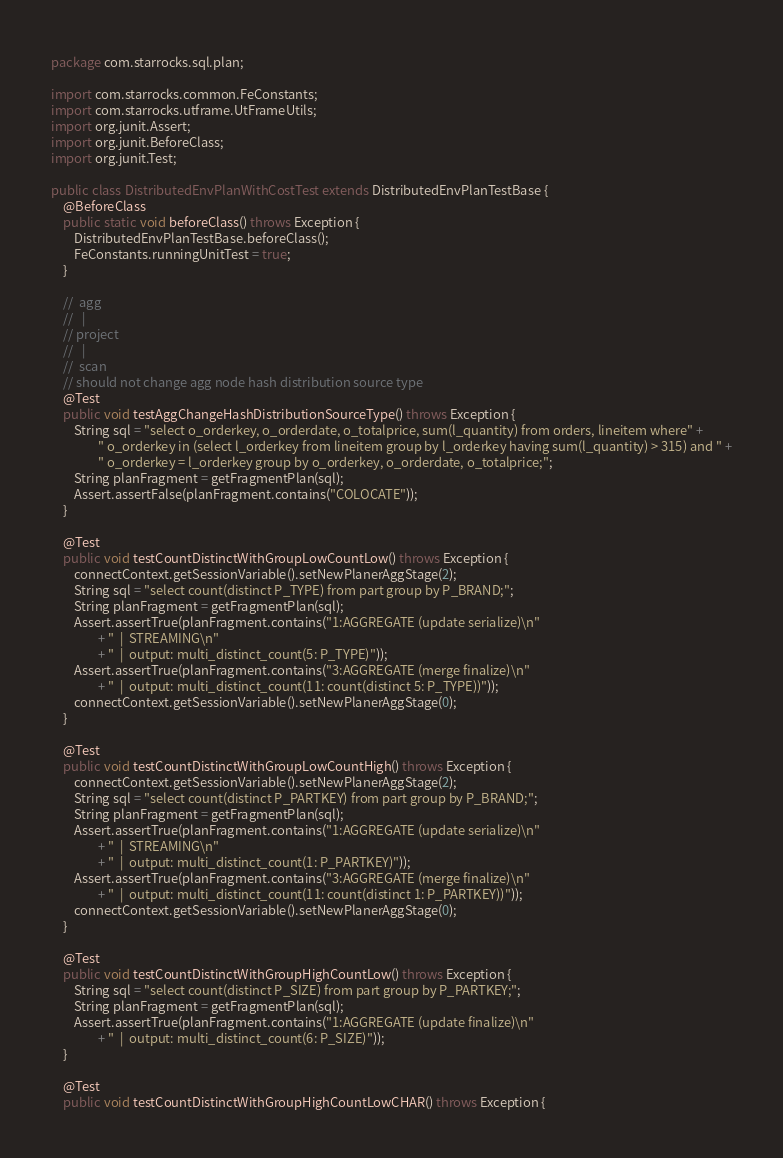Convert code to text. <code><loc_0><loc_0><loc_500><loc_500><_Java_>package com.starrocks.sql.plan;

import com.starrocks.common.FeConstants;
import com.starrocks.utframe.UtFrameUtils;
import org.junit.Assert;
import org.junit.BeforeClass;
import org.junit.Test;

public class DistributedEnvPlanWithCostTest extends DistributedEnvPlanTestBase {
    @BeforeClass
    public static void beforeClass() throws Exception {
        DistributedEnvPlanTestBase.beforeClass();
        FeConstants.runningUnitTest = true;
    }

    //  agg
    //   |
    // project
    //   |
    //  scan
    // should not change agg node hash distribution source type
    @Test
    public void testAggChangeHashDistributionSourceType() throws Exception {
        String sql = "select o_orderkey, o_orderdate, o_totalprice, sum(l_quantity) from orders, lineitem where" +
                " o_orderkey in (select l_orderkey from lineitem group by l_orderkey having sum(l_quantity) > 315) and " +
                " o_orderkey = l_orderkey group by o_orderkey, o_orderdate, o_totalprice;";
        String planFragment = getFragmentPlan(sql);
        Assert.assertFalse(planFragment.contains("COLOCATE"));
    }

    @Test
    public void testCountDistinctWithGroupLowCountLow() throws Exception {
        connectContext.getSessionVariable().setNewPlanerAggStage(2);
        String sql = "select count(distinct P_TYPE) from part group by P_BRAND;";
        String planFragment = getFragmentPlan(sql);
        Assert.assertTrue(planFragment.contains("1:AGGREGATE (update serialize)\n"
                + "  |  STREAMING\n"
                + "  |  output: multi_distinct_count(5: P_TYPE)"));
        Assert.assertTrue(planFragment.contains("3:AGGREGATE (merge finalize)\n"
                + "  |  output: multi_distinct_count(11: count(distinct 5: P_TYPE))"));
        connectContext.getSessionVariable().setNewPlanerAggStage(0);
    }

    @Test
    public void testCountDistinctWithGroupLowCountHigh() throws Exception {
        connectContext.getSessionVariable().setNewPlanerAggStage(2);
        String sql = "select count(distinct P_PARTKEY) from part group by P_BRAND;";
        String planFragment = getFragmentPlan(sql);
        Assert.assertTrue(planFragment.contains("1:AGGREGATE (update serialize)\n"
                + "  |  STREAMING\n"
                + "  |  output: multi_distinct_count(1: P_PARTKEY)"));
        Assert.assertTrue(planFragment.contains("3:AGGREGATE (merge finalize)\n"
                + "  |  output: multi_distinct_count(11: count(distinct 1: P_PARTKEY))"));
        connectContext.getSessionVariable().setNewPlanerAggStage(0);
    }

    @Test
    public void testCountDistinctWithGroupHighCountLow() throws Exception {
        String sql = "select count(distinct P_SIZE) from part group by P_PARTKEY;";
        String planFragment = getFragmentPlan(sql);
        Assert.assertTrue(planFragment.contains("1:AGGREGATE (update finalize)\n"
                + "  |  output: multi_distinct_count(6: P_SIZE)"));
    }

    @Test
    public void testCountDistinctWithGroupHighCountLowCHAR() throws Exception {</code> 